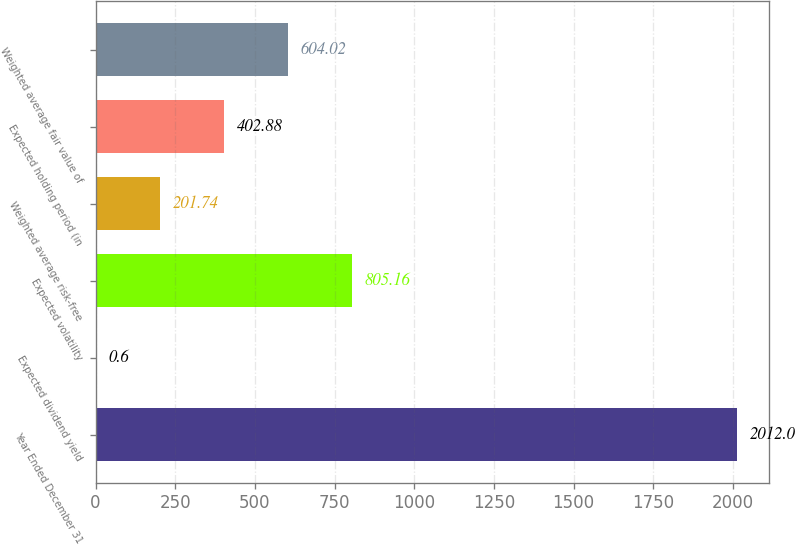Convert chart to OTSL. <chart><loc_0><loc_0><loc_500><loc_500><bar_chart><fcel>Year Ended December 31<fcel>Expected dividend yield<fcel>Expected volatility<fcel>Weighted average risk-free<fcel>Expected holding period (in<fcel>Weighted average fair value of<nl><fcel>2012<fcel>0.6<fcel>805.16<fcel>201.74<fcel>402.88<fcel>604.02<nl></chart> 